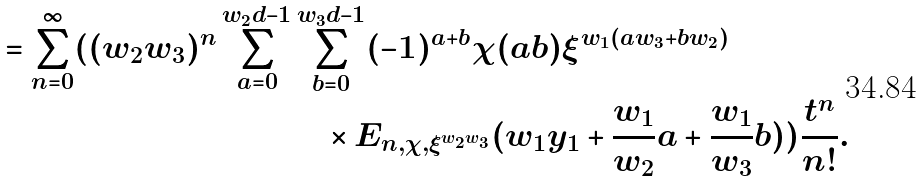Convert formula to latex. <formula><loc_0><loc_0><loc_500><loc_500>= \sum _ { n = 0 } ^ { \infty } ( ( w _ { 2 } w _ { 3 } ) ^ { n } \sum _ { a = 0 } ^ { w _ { 2 } d - 1 } & \sum _ { b = 0 } ^ { w _ { 3 } d - 1 } ( - 1 ) ^ { a + b } \chi ( a b ) \xi ^ { w _ { 1 } ( a w _ { 3 } + b w _ { 2 } ) } \\ & \quad \times E _ { n , \chi , \xi ^ { w _ { 2 } w _ { 3 } } } ( w _ { 1 } y _ { 1 } + \frac { w _ { 1 } } { w _ { 2 } } a + \frac { w _ { 1 } } { w _ { 3 } } b ) ) \frac { t ^ { n } } { n ! } .</formula> 